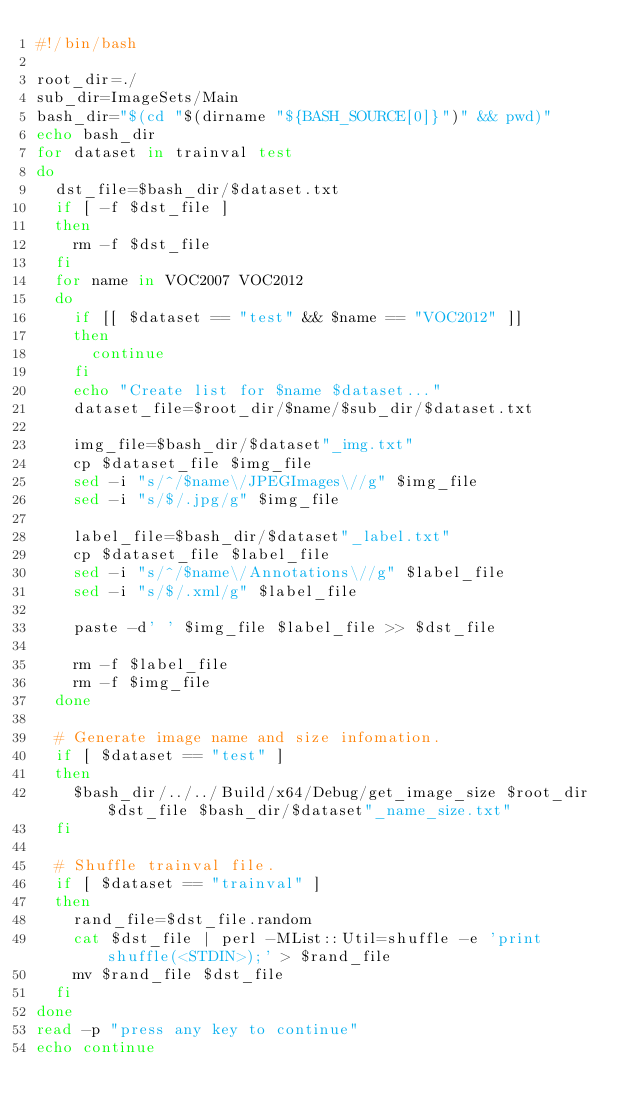<code> <loc_0><loc_0><loc_500><loc_500><_Bash_>#!/bin/bash

root_dir=./
sub_dir=ImageSets/Main
bash_dir="$(cd "$(dirname "${BASH_SOURCE[0]}")" && pwd)"
echo bash_dir
for dataset in trainval test
do
  dst_file=$bash_dir/$dataset.txt
  if [ -f $dst_file ]
  then
    rm -f $dst_file
  fi
  for name in VOC2007 VOC2012
  do
    if [[ $dataset == "test" && $name == "VOC2012" ]]
    then
      continue
    fi
    echo "Create list for $name $dataset..."
    dataset_file=$root_dir/$name/$sub_dir/$dataset.txt

    img_file=$bash_dir/$dataset"_img.txt"
    cp $dataset_file $img_file
    sed -i "s/^/$name\/JPEGImages\//g" $img_file
    sed -i "s/$/.jpg/g" $img_file

    label_file=$bash_dir/$dataset"_label.txt"
    cp $dataset_file $label_file
    sed -i "s/^/$name\/Annotations\//g" $label_file
    sed -i "s/$/.xml/g" $label_file

    paste -d' ' $img_file $label_file >> $dst_file

    rm -f $label_file
    rm -f $img_file
  done

  # Generate image name and size infomation.
  if [ $dataset == "test" ]
  then
    $bash_dir/../../Build/x64/Debug/get_image_size $root_dir $dst_file $bash_dir/$dataset"_name_size.txt"
  fi

  # Shuffle trainval file.
  if [ $dataset == "trainval" ]
  then
    rand_file=$dst_file.random
    cat $dst_file | perl -MList::Util=shuffle -e 'print shuffle(<STDIN>);' > $rand_file
    mv $rand_file $dst_file
  fi
done
read -p "press any key to continue"
echo continue
</code> 